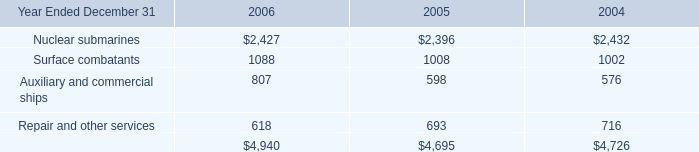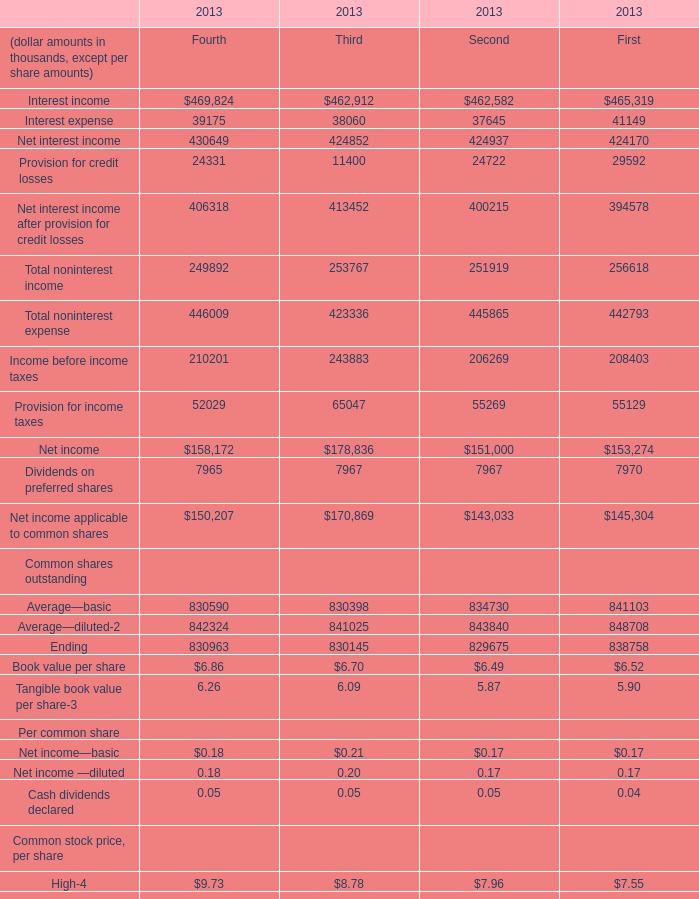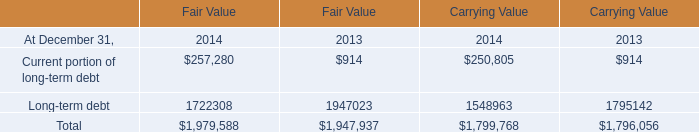What is the sum of Nuclear submarines of 2006, and Average—basic Common shares outstanding of 2013 First ? 
Computations: (2427.0 + 841103.0)
Answer: 843530.0. 